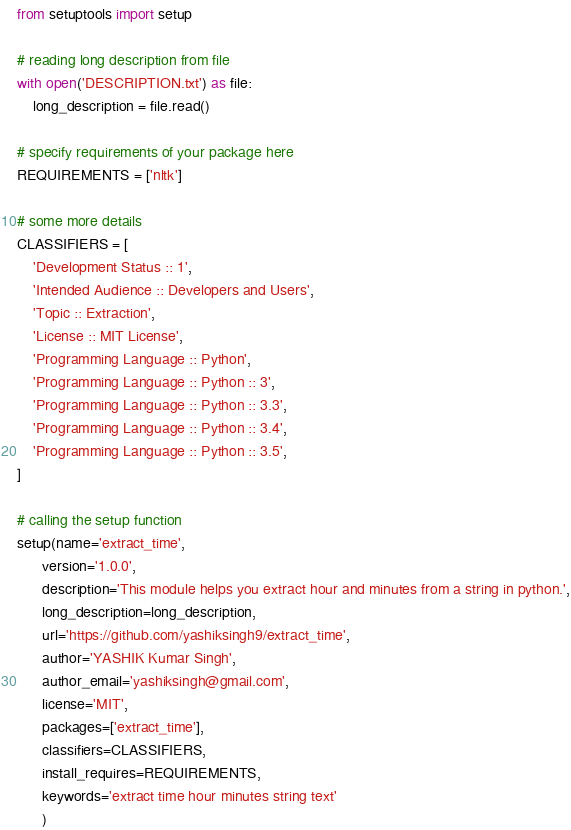<code> <loc_0><loc_0><loc_500><loc_500><_Python_>from setuptools import setup

# reading long description from file
with open('DESCRIPTION.txt') as file:
    long_description = file.read()

# specify requirements of your package here
REQUIREMENTS = ['nltk']

# some more details
CLASSIFIERS = [
    'Development Status :: 1',
    'Intended Audience :: Developers and Users',
    'Topic :: Extraction',
    'License :: MIT License',
    'Programming Language :: Python',
    'Programming Language :: Python :: 3',
    'Programming Language :: Python :: 3.3',
    'Programming Language :: Python :: 3.4',
    'Programming Language :: Python :: 3.5',
]

# calling the setup function
setup(name='extract_time',
      version='1.0.0',
      description='This module helps you extract hour and minutes from a string in python.',
      long_description=long_description,
      url='https://github.com/yashiksingh9/extract_time',
      author='YASHIK Kumar Singh',
      author_email='yashiksingh@gmail.com',
      license='MIT',
      packages=['extract_time'],
      classifiers=CLASSIFIERS,
      install_requires=REQUIREMENTS,
      keywords='extract time hour minutes string text'
      )</code> 